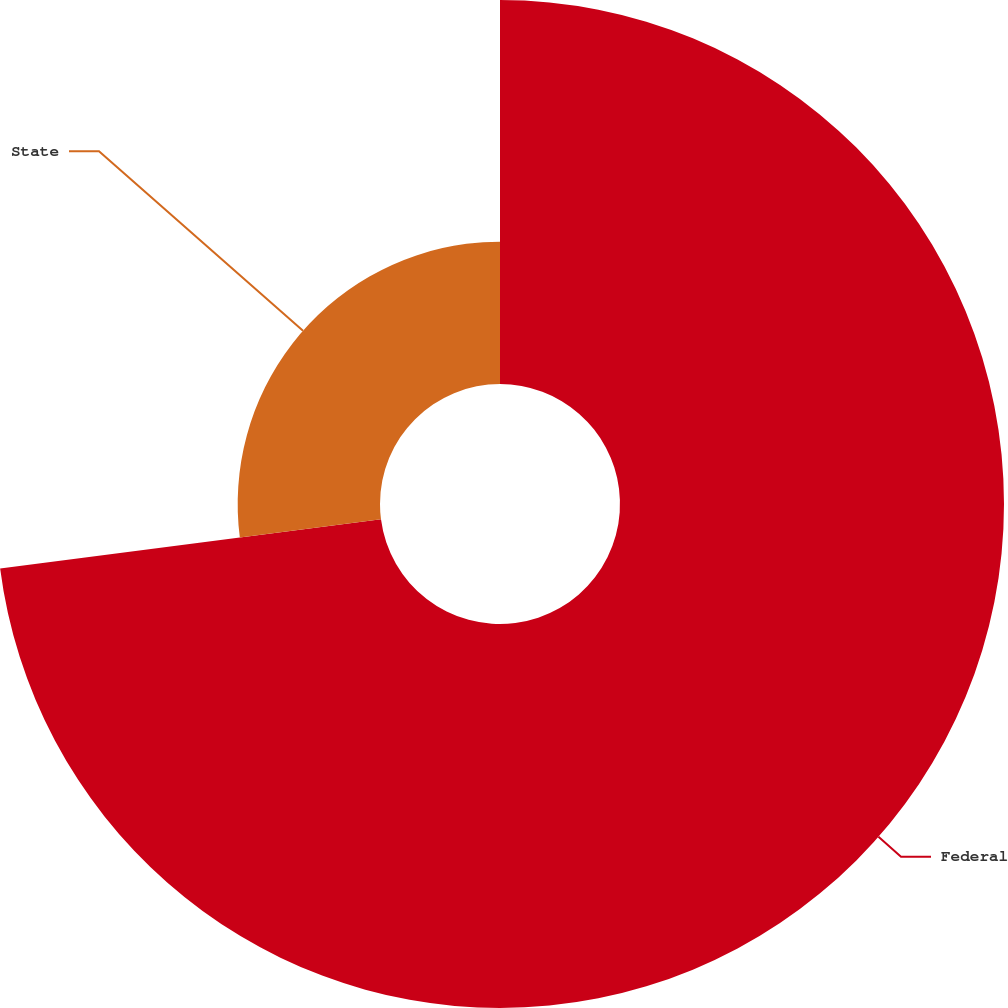<chart> <loc_0><loc_0><loc_500><loc_500><pie_chart><fcel>Federal<fcel>State<nl><fcel>72.96%<fcel>27.04%<nl></chart> 